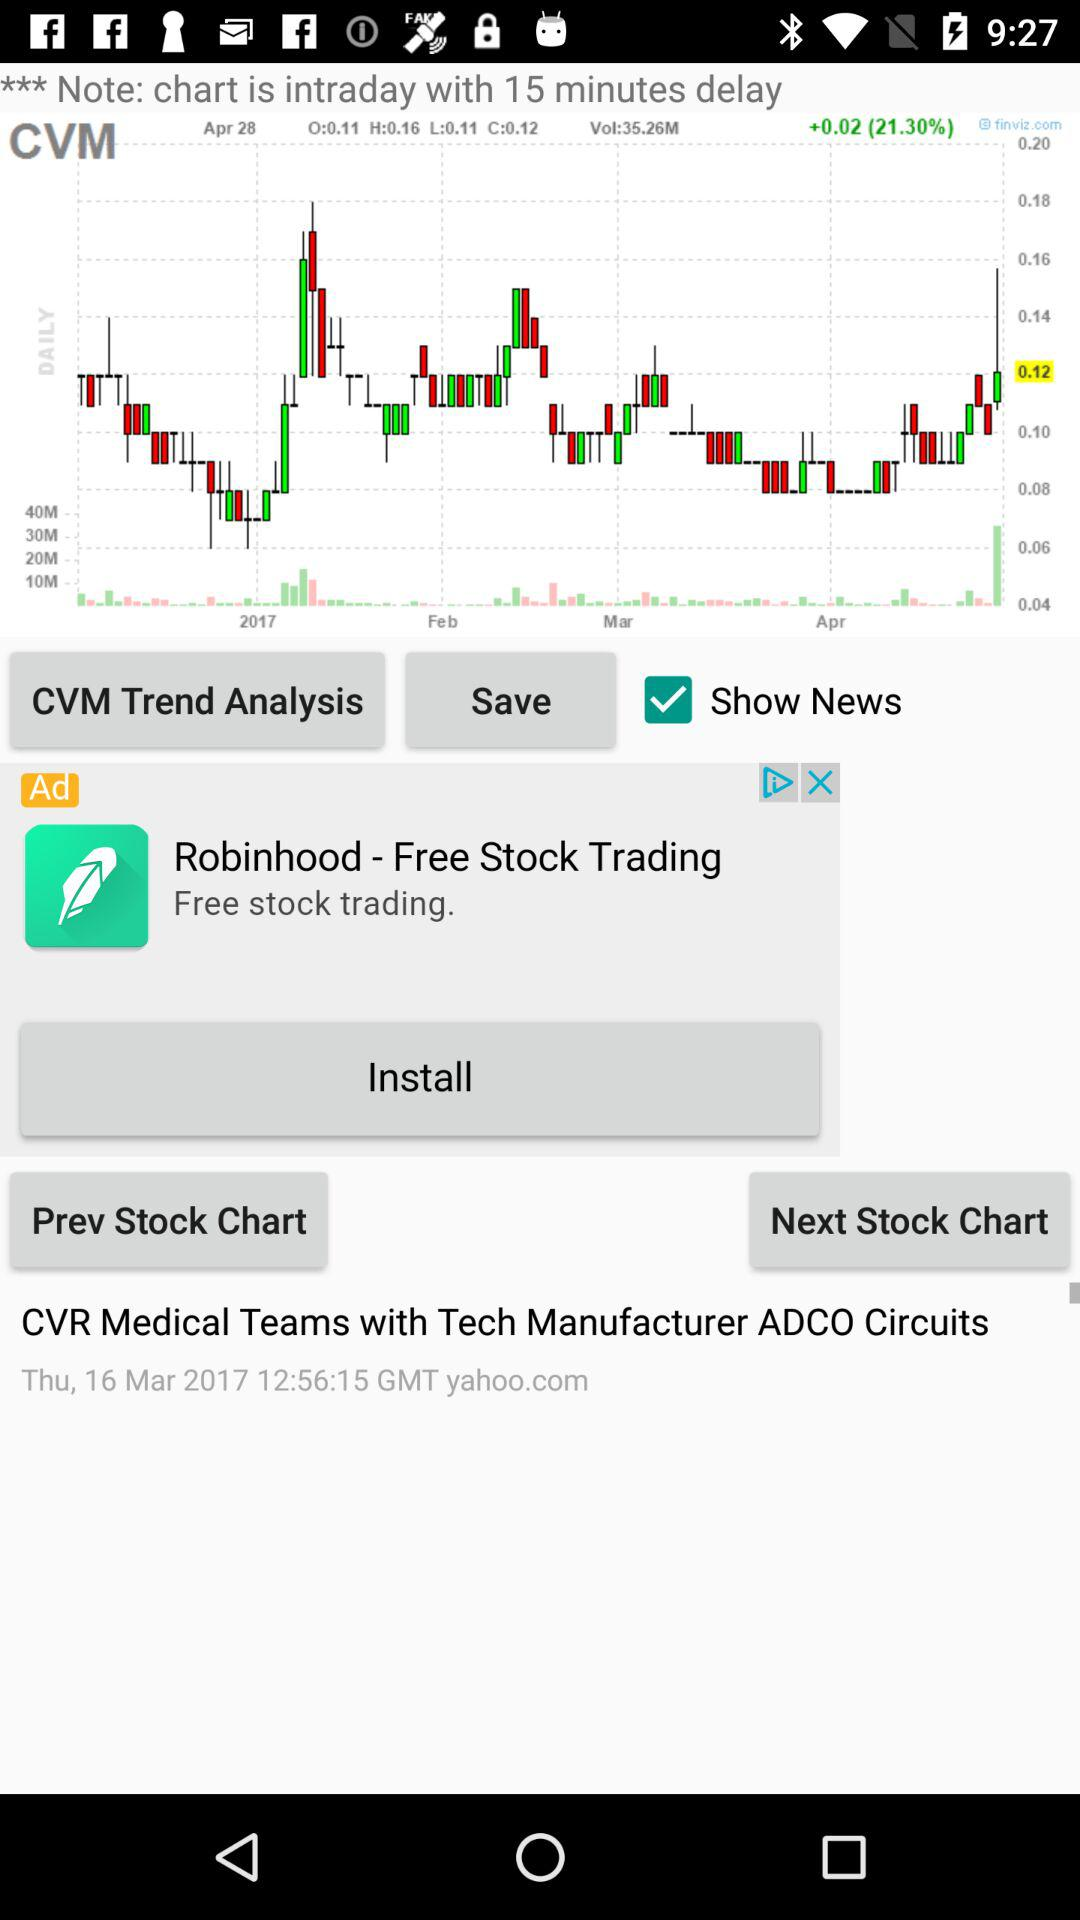What is the status of "Show News"? The status is "on". 